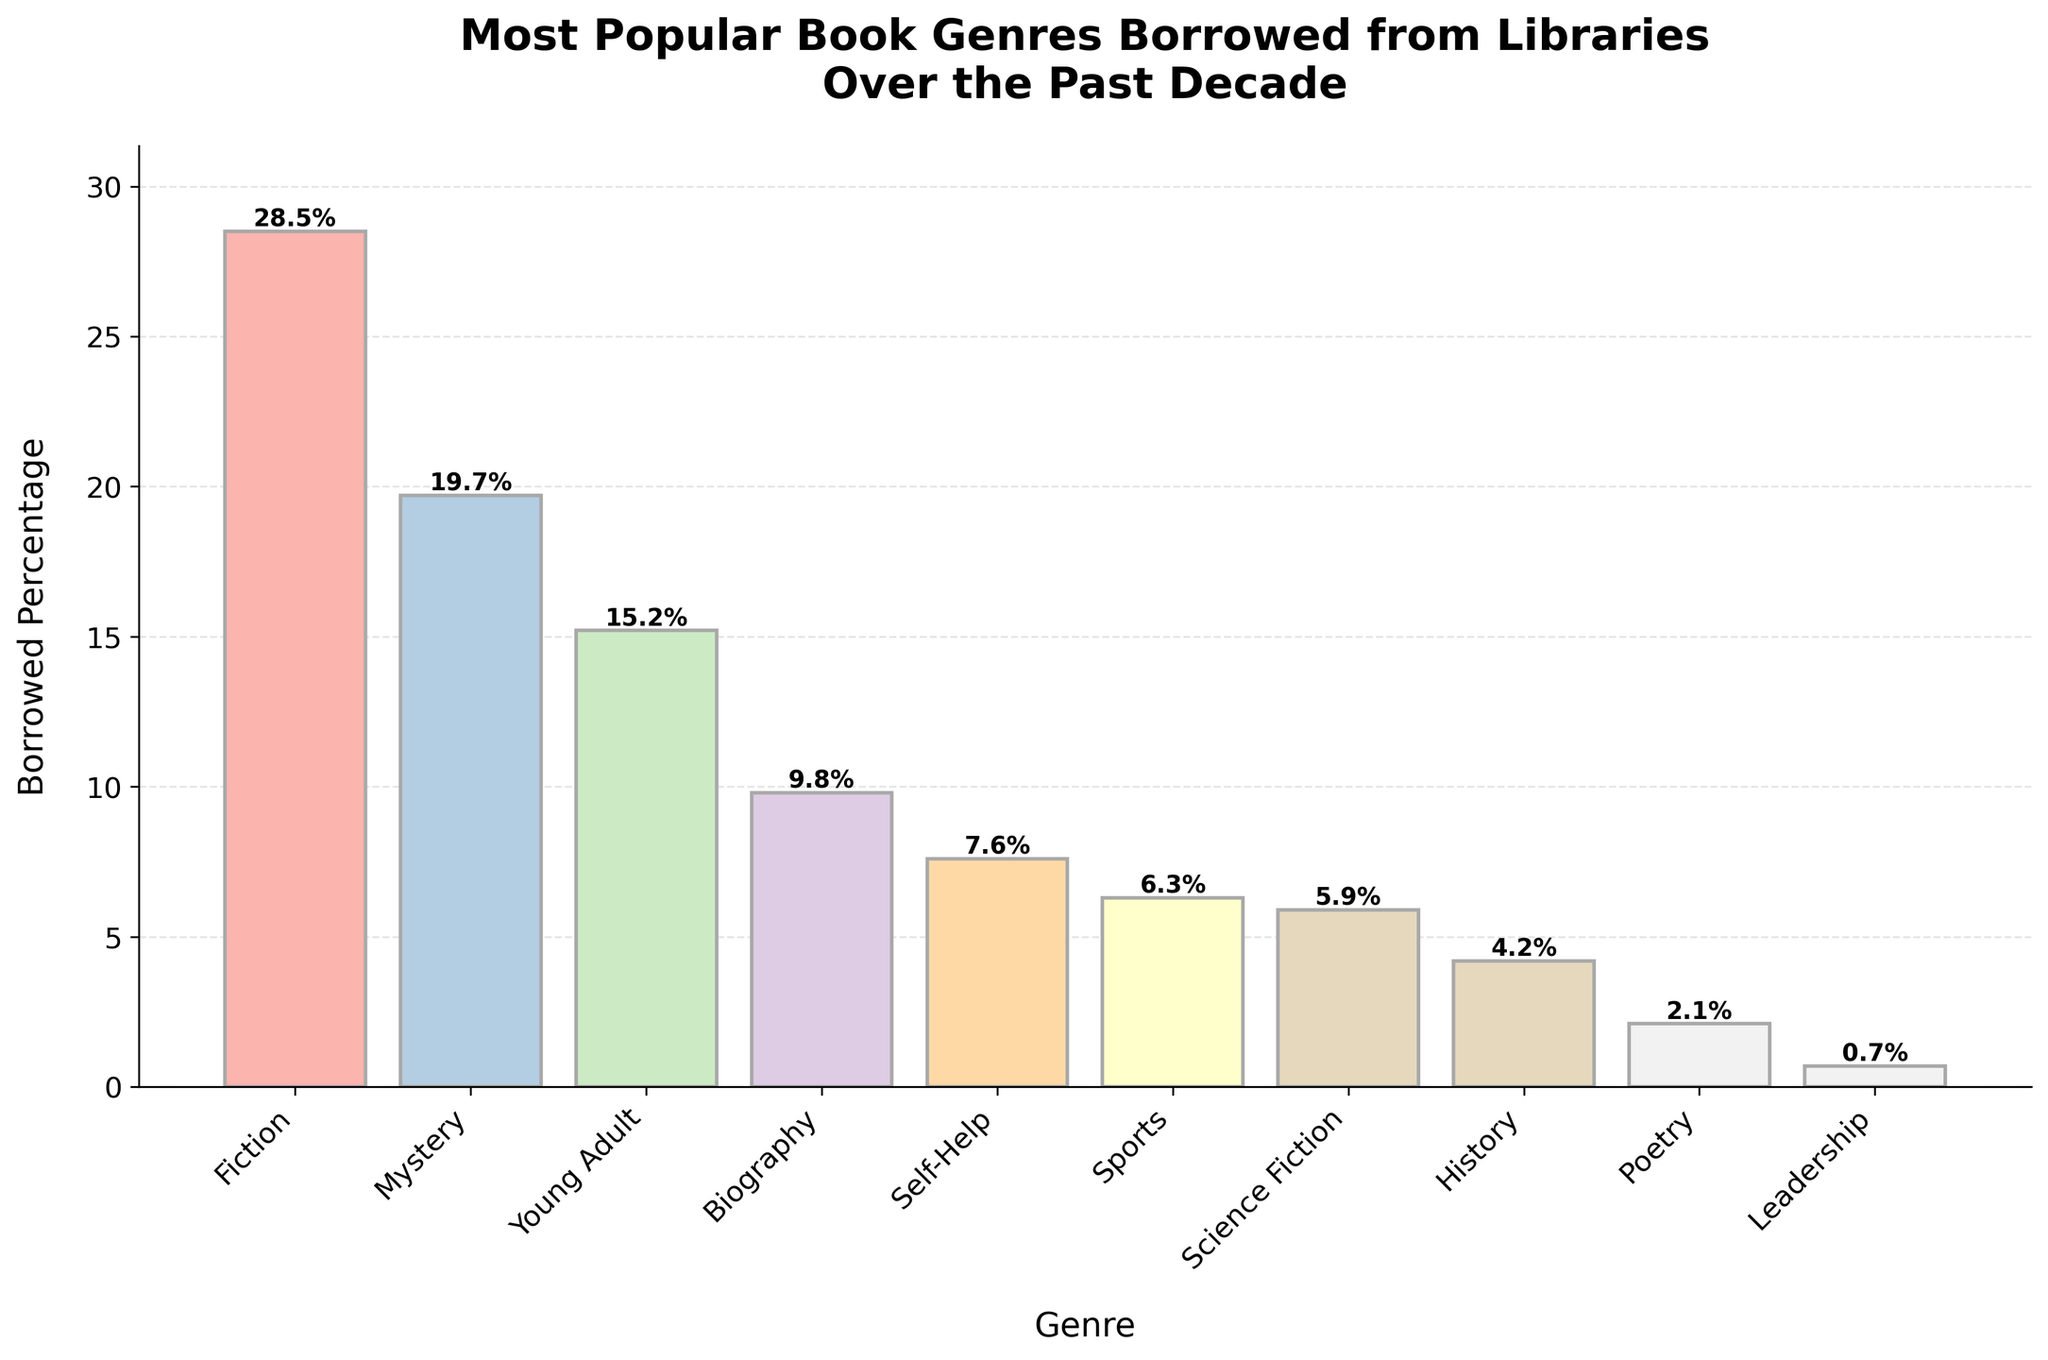Which genre has the highest percentage of books borrowed? By examining the height of the bars in the plot, we can identify which genre bar reaches the highest point. The tallest bar corresponds to Fiction.
Answer: Fiction Which two genres combined account for the largest percentage of books borrowed? The two tallest bars represent the genres Fiction and Mystery. Adding their borrowed percentages (28.5% + 19.7%) gives the total.
Answer: Fiction and Mystery How much higher is the borrowed percentage of Fiction than Leadership? We subtract the percentage of Leadership (0.7%) from the percentage of Fiction (28.5%).
Answer: 27.8% What is the total borrowed percentage for Fiction, Young Adult, and Sports combined? Summing the percentages for the genres Fiction (28.5%), Young Adult (15.2%), and Sports (6.3%) gives the total.
Answer: 50% Which genre has the smallest percentage of books borrowed? The shortest bar on the chart represents the genre with the smallest percentage. This is Leadership at 0.7%.
Answer: Leadership Are Mystery books borrowed more frequently than Young Adult books? By comparing the heights of the bars for Mystery and Young Adult, we see that the bar for Mystery is higher.
Answer: Yes What percentage larger is the borrowed percentage of Biography compared to Poetry? To find this, subtract the percentage of Poetry (2.1%) from the percentage of Biography (9.8%).
Answer: 7.7% Which genres have a borrowed percentage below 10%? By looking at the bars that are less than 10% in height, we identify Biography (9.8%), Self-Help (7.6%), Sports (6.3%), Science Fiction (5.9%), History (4.2%), Poetry (2.1%), and Leadership (0.7%).
Answer: Biography, Self-Help, Sports, Science Fiction, History, Poetry, Leadership Which genre has a borrowed percentage closest to 5%? By comparing the percentages around 5%, we find that Science Fiction at 5.9% is closest.
Answer: Science Fiction 